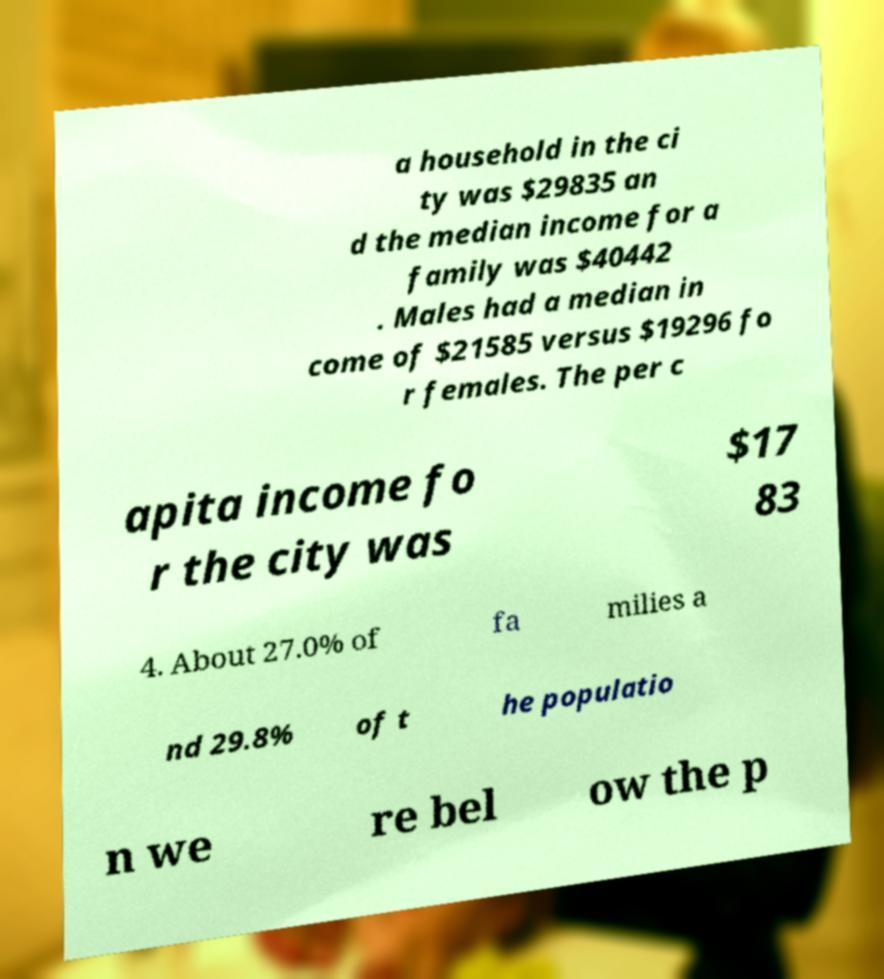Could you assist in decoding the text presented in this image and type it out clearly? a household in the ci ty was $29835 an d the median income for a family was $40442 . Males had a median in come of $21585 versus $19296 fo r females. The per c apita income fo r the city was $17 83 4. About 27.0% of fa milies a nd 29.8% of t he populatio n we re bel ow the p 